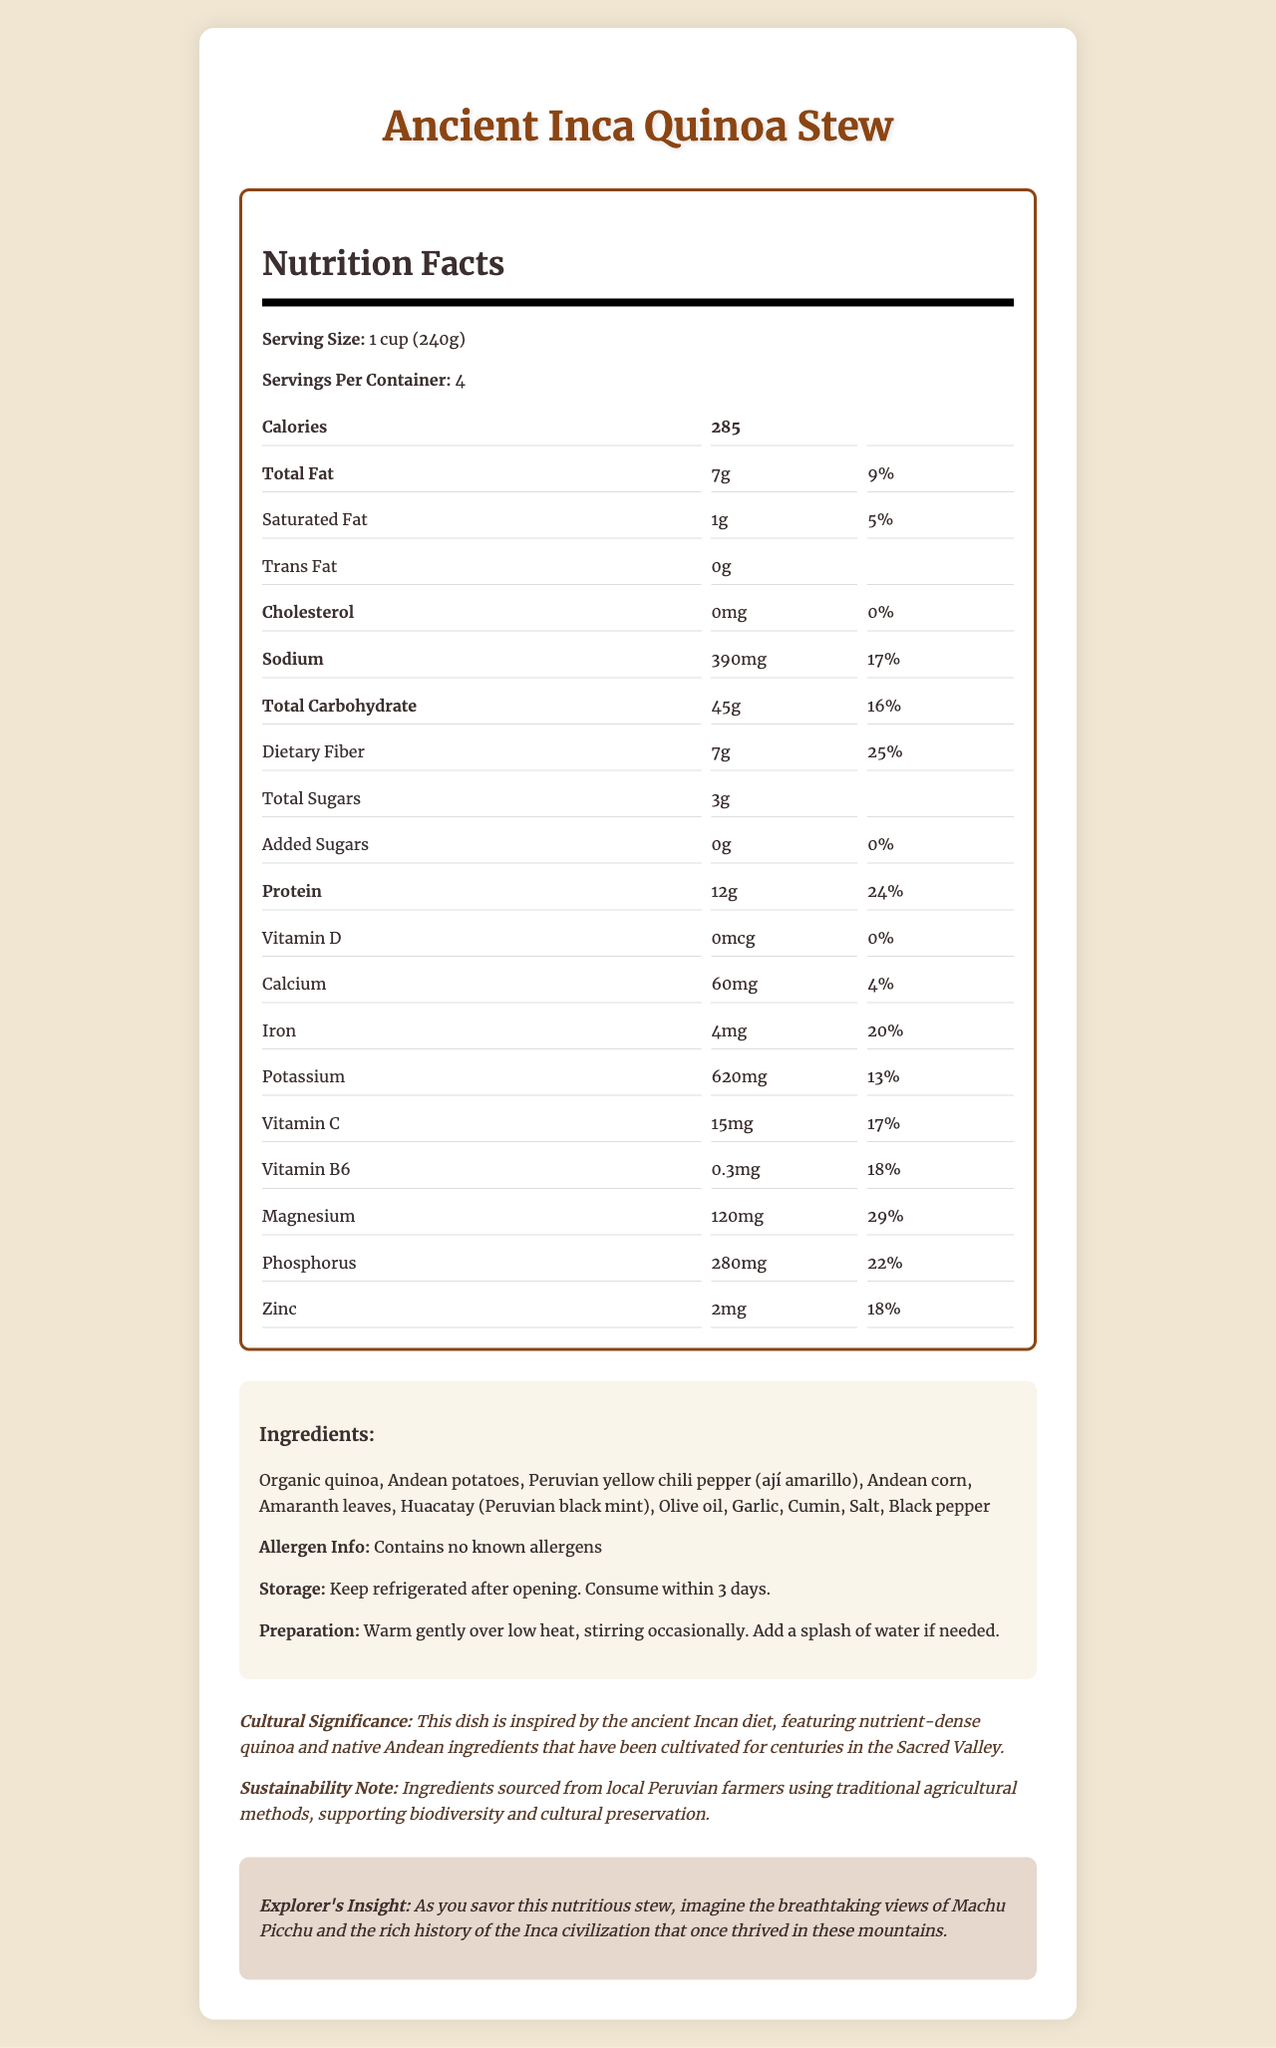what is the serving size of the Ancient Inca Quinoa Stew? The serving size is directly mentioned as "1 cup (240g)" in the Nutrition Facts section.
Answer: 1 cup (240g) how many servings are there per container? The document states there are 4 servings per container.
Answer: 4 how much dietary fiber is in one serving? The dietary fiber amount per serving is listed as "7g" in the Nutrition Facts section.
Answer: 7g how much protein is in one serving of the stew? The protein amount per serving is provided as "12g" in the document.
Answer: 12g what are the main ingredients used in the Ancient Inca Quinoa Stew? These ingredients are listed under the Ingredients section in the document.
Answer: Organic quinoa, Andean potatoes, Peruvian yellow chili pepper (ají amarillo), Andean corn, Amaranth leaves, Huacatay (Peruvian black mint), Olive oil, Garlic, Cumin, Salt, Black pepper how much saturated fat does one serving contain? The amount of saturated fat is listed as "1g" under the Nutrition Facts section.
Answer: 1g what percentage of daily value of magnesium does the stew provide? The daily value for magnesium is specified as 29% in the Nutrition Facts section.
Answer: 29% does the stew contain any trans fat? The amount of trans fat is listed as "0g" which indicates there are no trans fats present.
Answer: No how much Vitamin C is there per serving? The amount of Vitamin C per serving is mentioned as "15mg".
Answer: 15mg what is the total fat content per serving, and what is the corresponding daily value percentage? The total fat content per serving is 7g and it constitutes 9% of the daily value.
Answer: 7g, 9% how many calories are there per serving? The document indicates there are 285 calories per serving.
Answer: 285 how should the stew be stored after opening? The storage instructions mention to keep it refrigerated after opening, and it should be consumed within 3 days.
Answer: Keep refrigerated after opening. Consume within 3 days. which of the following is NOT listed as an ingredient in the Ancient Inca Quinoa Stew? A. Organic quinoa B. Andean potatoes C. Tomatoes D. Peruvian yellow chili pepper Tomatoes are not part of the listed ingredients in the document.
Answer: C. Tomatoes which nutrient has the highest daily value percentage per serving? A. Dietary fiber B. Protein C. Magnesium D. Iron The daily value for dietary fiber is 25%, which is the highest among the listed nutrients.
Answer: A. Dietary fiber is the stew free from any known allergens? The allergen info section states that the stew contains no known allergens.
Answer: Yes describe the cultural significance and sustainability note for this dish. The document describes the cultural significance as being inspired by the ancient Incan diet and mentions that the ingredients are traditionally cultivated. It also highlights the sustainability note about sourcing from local farmers and supporting biodiversity and cultural preservation.
Answer: The Ancient Inca Quinoa Stew is inspired by the ancient Incan diet featuring nutrient-dense quinoa and native Andean ingredients cultivated for centuries in the Sacred Valley. The ingredients are sourced from local Peruvian farmers using traditional agricultural methods, supporting biodiversity and cultural preservation. how many calories come from carbohydrates in one serving? The document provides the total calories and the amount of carbohydrates, but it doesn't specify the exact calorie contribution from carbohydrates. To calculate this, additional data such as the exact caloric contribution per gram of carbohydrate would be needed.
Answer: Not enough information 